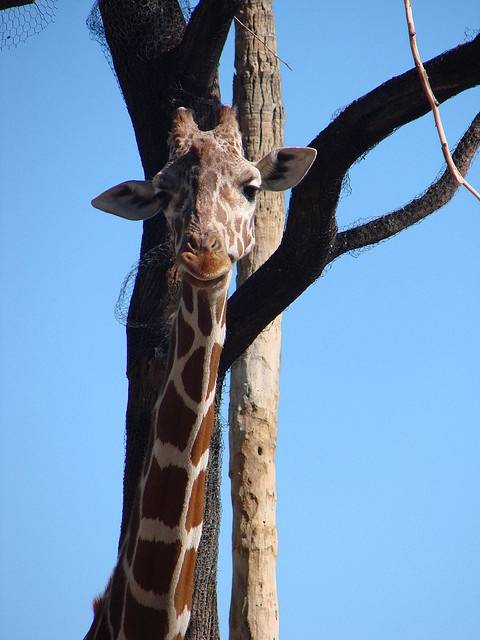Describe the objects in this image and their specific colors. I can see a giraffe in black, gray, and maroon tones in this image. 